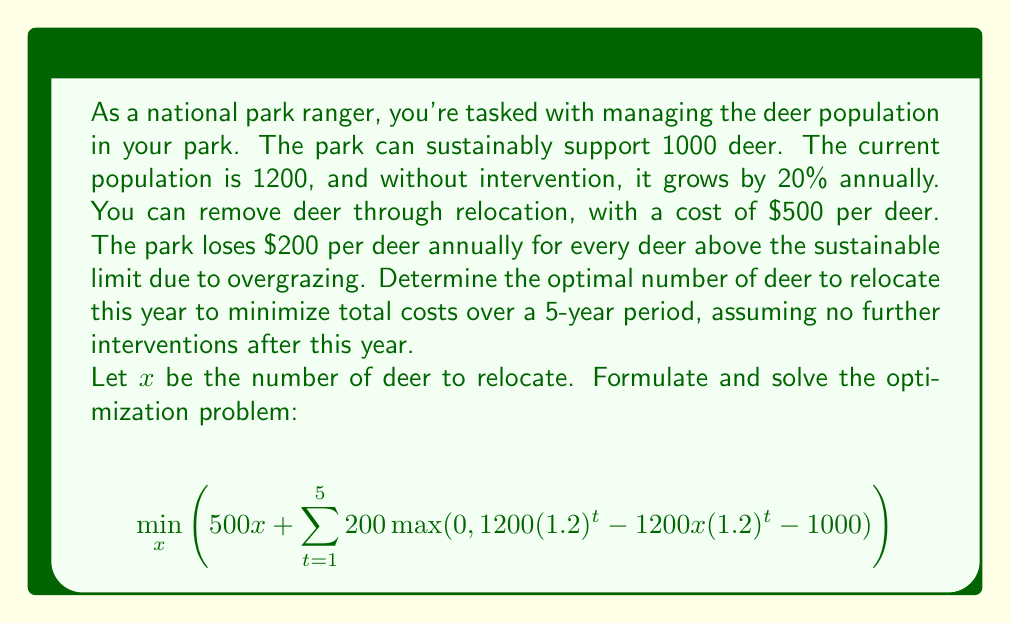Can you answer this question? To solve this problem, we'll follow these steps:

1) First, let's understand what the equation represents:
   - $500x$ is the cost of relocating $x$ deer this year
   - The summation represents the overgrazing costs for the next 5 years

2) Let's expand the summation:
   $$500x + 200 \max(0, 1440 - 1.2x - 1000) + 200 \max(0, 1728 - 1.44x - 1000) + \\
   200 \max(0, 2074 - 1.728x - 1000) + 200 \max(0, 2489 - 2.074x - 1000) + \\
   200 \max(0, 2986 - 2.489x - 1000)$$

3) Now, we need to find the values of $x$ where each $\max$ function changes from 0 to a positive value:
   - Year 1: $1440 - 1.2x - 1000 = 0 \implies x = 366.67$
   - Year 2: $1728 - 1.44x - 1000 = 0 \implies x = 506.94$
   - Year 3: $2074 - 1.728x - 1000 = 0 \implies x = 621.53$
   - Year 4: $2489 - 2.074x - 1000 = 0 \implies x = 717.94$
   - Year 5: $2986 - 2.489x - 1000 = 0 \implies x = 798.31$

4) These values divide the domain of $x$ into 6 intervals. We need to evaluate the function at each interval boundary and at any critical points within each interval.

5) The derivative of the function within each interval (where it's differentiable) is constant. So, the minimum will occur at one of the interval boundaries.

6) Evaluating the function at each boundary:
   - $x = 366.67$: Cost ≈ $183,335 + 200(0 + 161 + 596 + 1251 + 2186) = $637,335
   - $x = 506.94$: Cost ≈ $253,470 + 200(0 + 0 + 75 + 451 + 1086) = $575,470
   - $x = 621.53$: Cost ≈ $310,765 + 200(0 + 0 + 0 + 39 + 437) = $386,765
   - $x = 717.94$: Cost ≈ $358,970 + 200(0 + 0 + 0 + 0 + 15) = $361,970
   - $x = 798.31$: Cost ≈ $399,155 + 200(0 + 0 + 0 + 0 + 0) = $399,155

7) The minimum cost occurs at $x = 717.94$, which we round to 718 deer.
Answer: The optimal number of deer to relocate this year is 718, which minimizes the total cost over the 5-year period to approximately $361,970. 